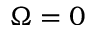<formula> <loc_0><loc_0><loc_500><loc_500>\Omega = 0</formula> 